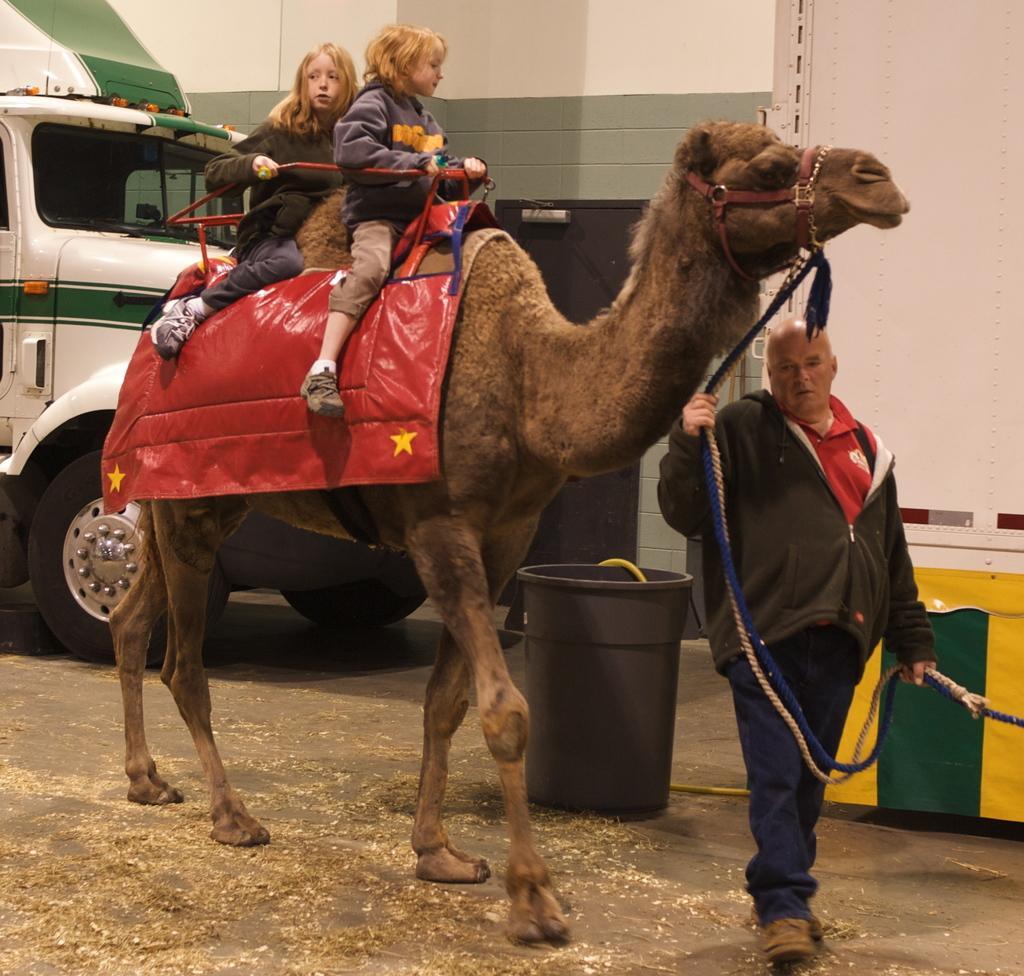How would you summarize this image in a sentence or two? In this picture, there is a camel facing towards the right. On the camel, there are two kids. Towards the right, there is a man holding a rope which is attached to the camel. Behind him, there is a basket. In the background, there is a vehicle and a wall. 